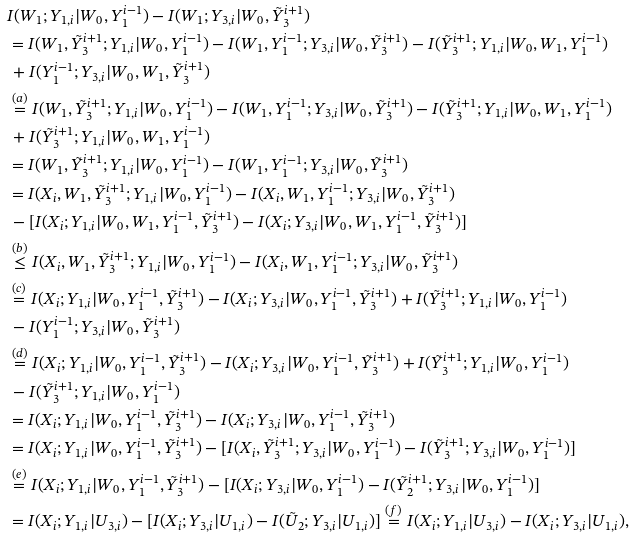<formula> <loc_0><loc_0><loc_500><loc_500>& I ( W _ { 1 } ; Y _ { 1 , i } | W _ { 0 } , Y _ { 1 } ^ { i - 1 } ) - I ( W _ { 1 } ; Y _ { 3 , i } | W _ { 0 } , \tilde { Y } _ { 3 } ^ { i + 1 } ) \\ & = I ( W _ { 1 } , \tilde { Y } _ { 3 } ^ { i + 1 } ; Y _ { 1 , i } | W _ { 0 } , Y _ { 1 } ^ { i - 1 } ) - I ( W _ { 1 } , Y _ { 1 } ^ { i - 1 } ; Y _ { 3 , i } | W _ { 0 } , \tilde { Y } _ { 3 } ^ { i + 1 } ) - I ( \tilde { Y } _ { 3 } ^ { i + 1 } ; Y _ { 1 , i } | W _ { 0 } , W _ { 1 } , Y _ { 1 } ^ { i - 1 } ) \\ & \, + I ( Y _ { 1 } ^ { i - 1 } ; Y _ { 3 , i } | W _ { 0 } , W _ { 1 } , \tilde { Y } _ { 3 } ^ { i + 1 } ) \\ & \stackrel { ( a ) } { = } I ( W _ { 1 } , \tilde { Y } _ { 3 } ^ { i + 1 } ; Y _ { 1 , i } | W _ { 0 } , Y _ { 1 } ^ { i - 1 } ) - I ( W _ { 1 } , Y _ { 1 } ^ { i - 1 } ; Y _ { 3 , i } | W _ { 0 } , \tilde { Y } _ { 3 } ^ { i + 1 } ) - I ( \tilde { Y } _ { 3 } ^ { i + 1 } ; Y _ { 1 , i } | W _ { 0 } , W _ { 1 } , Y _ { 1 } ^ { i - 1 } ) \\ & \, + I ( \tilde { Y } _ { 3 } ^ { i + 1 } ; Y _ { 1 , i } | W _ { 0 } , W _ { 1 } , Y _ { 1 } ^ { i - 1 } ) \\ & = I ( W _ { 1 } , \tilde { Y } _ { 3 } ^ { i + 1 } ; Y _ { 1 , i } | W _ { 0 } , Y _ { 1 } ^ { i - 1 } ) - I ( W _ { 1 } , Y _ { 1 } ^ { i - 1 } ; Y _ { 3 , i } | W _ { 0 } , \tilde { Y } _ { 3 } ^ { i + 1 } ) \\ & = I ( X _ { i } , W _ { 1 } , \tilde { Y } _ { 3 } ^ { i + 1 } ; Y _ { 1 , i } | W _ { 0 } , Y _ { 1 } ^ { i - 1 } ) - I ( X _ { i } , W _ { 1 } , Y _ { 1 } ^ { i - 1 } ; Y _ { 3 , i } | W _ { 0 } , \tilde { Y } _ { 3 } ^ { i + 1 } ) \\ & \, - [ I ( X _ { i } ; Y _ { 1 , i } | W _ { 0 } , W _ { 1 } , Y _ { 1 } ^ { i - 1 } , \tilde { Y } _ { 3 } ^ { i + 1 } ) - I ( X _ { i } ; Y _ { 3 , i } | W _ { 0 } , W _ { 1 } , Y _ { 1 } ^ { i - 1 } , \tilde { Y } _ { 3 } ^ { i + 1 } ) ] \\ & \stackrel { ( b ) } { \leq } I ( X _ { i } , W _ { 1 } , \tilde { Y } _ { 3 } ^ { i + 1 } ; Y _ { 1 , i } | W _ { 0 } , Y _ { 1 } ^ { i - 1 } ) - I ( X _ { i } , W _ { 1 } , Y _ { 1 } ^ { i - 1 } ; Y _ { 3 , i } | W _ { 0 } , \tilde { Y } _ { 3 } ^ { i + 1 } ) \\ & \stackrel { ( c ) } { = } I ( X _ { i } ; Y _ { 1 , i } | W _ { 0 } , Y _ { 1 } ^ { i - 1 } , \tilde { Y } _ { 3 } ^ { i + 1 } ) - I ( X _ { i } ; Y _ { 3 , i } | W _ { 0 } , Y _ { 1 } ^ { i - 1 } , \tilde { Y } _ { 3 } ^ { i + 1 } ) + I ( \tilde { Y } _ { 3 } ^ { i + 1 } ; Y _ { 1 , i } | W _ { 0 } , Y _ { 1 } ^ { i - 1 } ) \\ & \, - I ( Y _ { 1 } ^ { i - 1 } ; Y _ { 3 , i } | W _ { 0 } , \tilde { Y } _ { 3 } ^ { i + 1 } ) \\ & \stackrel { ( d ) } { = } I ( X _ { i } ; Y _ { 1 , i } | W _ { 0 } , Y _ { 1 } ^ { i - 1 } , \tilde { Y } _ { 3 } ^ { i + 1 } ) - I ( X _ { i } ; Y _ { 3 , i } | W _ { 0 } , Y _ { 1 } ^ { i - 1 } , \tilde { Y } _ { 3 } ^ { i + 1 } ) + I ( \tilde { Y } _ { 3 } ^ { i + 1 } ; Y _ { 1 , i } | W _ { 0 } , Y _ { 1 } ^ { i - 1 } ) \\ & \, - I ( \tilde { Y } _ { 3 } ^ { i + 1 } ; Y _ { 1 , i } | W _ { 0 } , Y _ { 1 } ^ { i - 1 } ) \\ & = I ( X _ { i } ; Y _ { 1 , i } | W _ { 0 } , Y _ { 1 } ^ { i - 1 } , \tilde { Y } _ { 3 } ^ { i + 1 } ) - I ( X _ { i } ; Y _ { 3 , i } | W _ { 0 } , Y _ { 1 } ^ { i - 1 } , \tilde { Y } _ { 3 } ^ { i + 1 } ) \\ & = I ( X _ { i } ; Y _ { 1 , i } | W _ { 0 } , Y _ { 1 } ^ { i - 1 } , \tilde { Y } _ { 3 } ^ { i + 1 } ) - [ I ( X _ { i } , \tilde { Y } _ { 3 } ^ { i + 1 } ; Y _ { 3 , i } | W _ { 0 } , Y _ { 1 } ^ { i - 1 } ) - I ( \tilde { Y } _ { 3 } ^ { i + 1 } ; Y _ { 3 , i } | W _ { 0 } , Y _ { 1 } ^ { i - 1 } ) ] \\ & \stackrel { ( e ) } { = } I ( X _ { i } ; Y _ { 1 , i } | W _ { 0 } , Y _ { 1 } ^ { i - 1 } , \tilde { Y } _ { 3 } ^ { i + 1 } ) - [ I ( X _ { i } ; Y _ { 3 , i } | W _ { 0 } , Y _ { 1 } ^ { i - 1 } ) - I ( \tilde { Y } _ { 2 } ^ { i + 1 } ; Y _ { 3 , i } | W _ { 0 } , Y _ { 1 } ^ { i - 1 } ) ] \\ & = I ( X _ { i } ; Y _ { 1 , i } | U _ { 3 , i } ) - [ I ( X _ { i } ; Y _ { 3 , i } | U _ { 1 , i } ) - I ( \tilde { U } _ { 2 } ; Y _ { 3 , i } | U _ { 1 , i } ) ] \stackrel { ( f ) } { = } I ( X _ { i } ; Y _ { 1 , i } | U _ { 3 , i } ) - I ( X _ { i } ; Y _ { 3 , i } | U _ { 1 , i } ) ,</formula> 